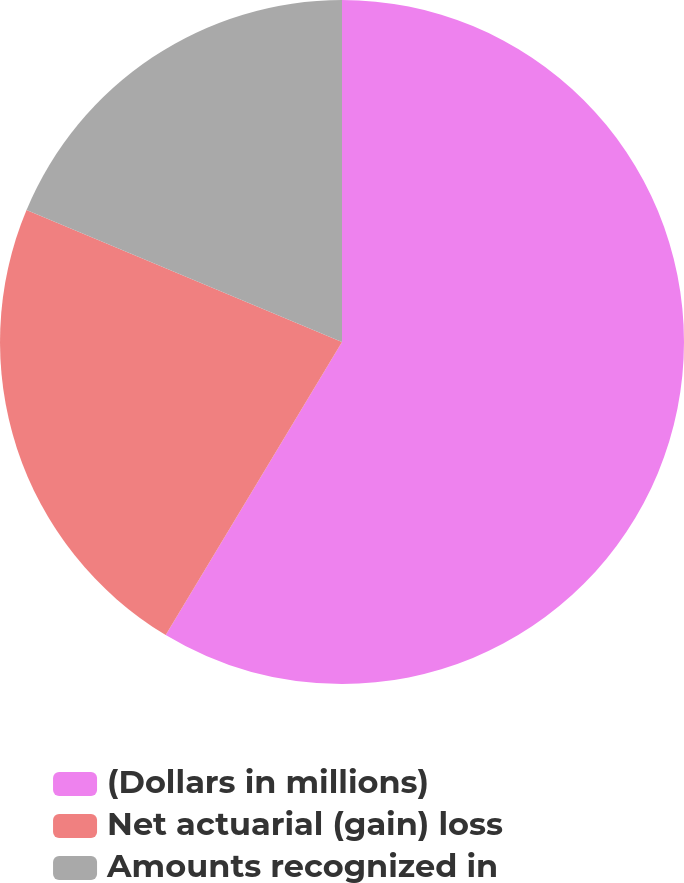Convert chart. <chart><loc_0><loc_0><loc_500><loc_500><pie_chart><fcel>(Dollars in millions)<fcel>Net actuarial (gain) loss<fcel>Amounts recognized in<nl><fcel>58.62%<fcel>22.69%<fcel>18.69%<nl></chart> 